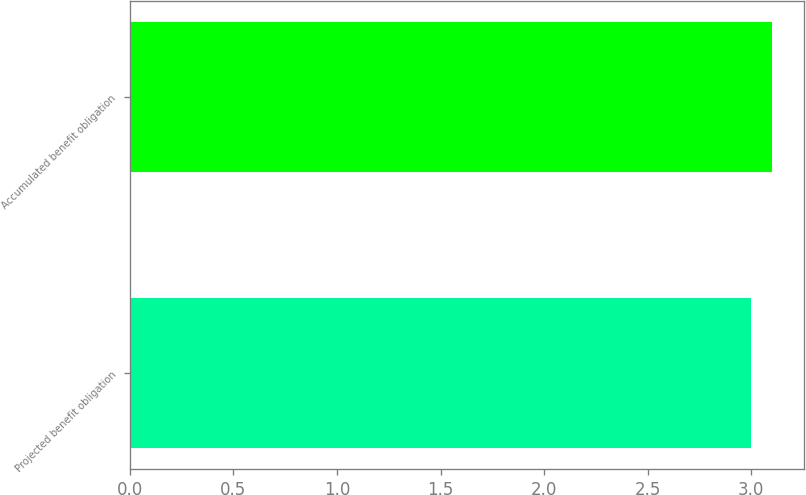Convert chart. <chart><loc_0><loc_0><loc_500><loc_500><bar_chart><fcel>Projected benefit obligation<fcel>Accumulated benefit obligation<nl><fcel>3<fcel>3.1<nl></chart> 